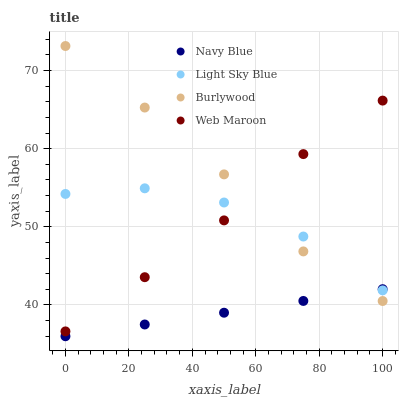Does Navy Blue have the minimum area under the curve?
Answer yes or no. Yes. Does Burlywood have the maximum area under the curve?
Answer yes or no. Yes. Does Light Sky Blue have the minimum area under the curve?
Answer yes or no. No. Does Light Sky Blue have the maximum area under the curve?
Answer yes or no. No. Is Navy Blue the smoothest?
Answer yes or no. Yes. Is Light Sky Blue the roughest?
Answer yes or no. Yes. Is Light Sky Blue the smoothest?
Answer yes or no. No. Is Navy Blue the roughest?
Answer yes or no. No. Does Navy Blue have the lowest value?
Answer yes or no. Yes. Does Light Sky Blue have the lowest value?
Answer yes or no. No. Does Burlywood have the highest value?
Answer yes or no. Yes. Does Light Sky Blue have the highest value?
Answer yes or no. No. Is Navy Blue less than Web Maroon?
Answer yes or no. Yes. Is Web Maroon greater than Navy Blue?
Answer yes or no. Yes. Does Light Sky Blue intersect Burlywood?
Answer yes or no. Yes. Is Light Sky Blue less than Burlywood?
Answer yes or no. No. Is Light Sky Blue greater than Burlywood?
Answer yes or no. No. Does Navy Blue intersect Web Maroon?
Answer yes or no. No. 